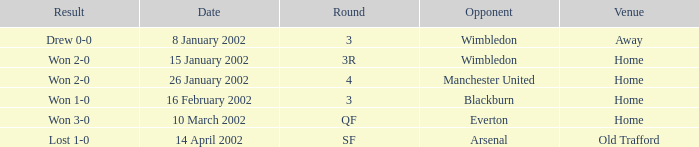Can you give me this table as a dict? {'header': ['Result', 'Date', 'Round', 'Opponent', 'Venue'], 'rows': [['Drew 0-0', '8 January 2002', '3', 'Wimbledon', 'Away'], ['Won 2-0', '15 January 2002', '3R', 'Wimbledon', 'Home'], ['Won 2-0', '26 January 2002', '4', 'Manchester United', 'Home'], ['Won 1-0', '16 February 2002', '3', 'Blackburn', 'Home'], ['Won 3-0', '10 March 2002', 'QF', 'Everton', 'Home'], ['Lost 1-0', '14 April 2002', 'SF', 'Arsenal', 'Old Trafford']]} What is the Round with a Opponent with blackburn? 3.0. 